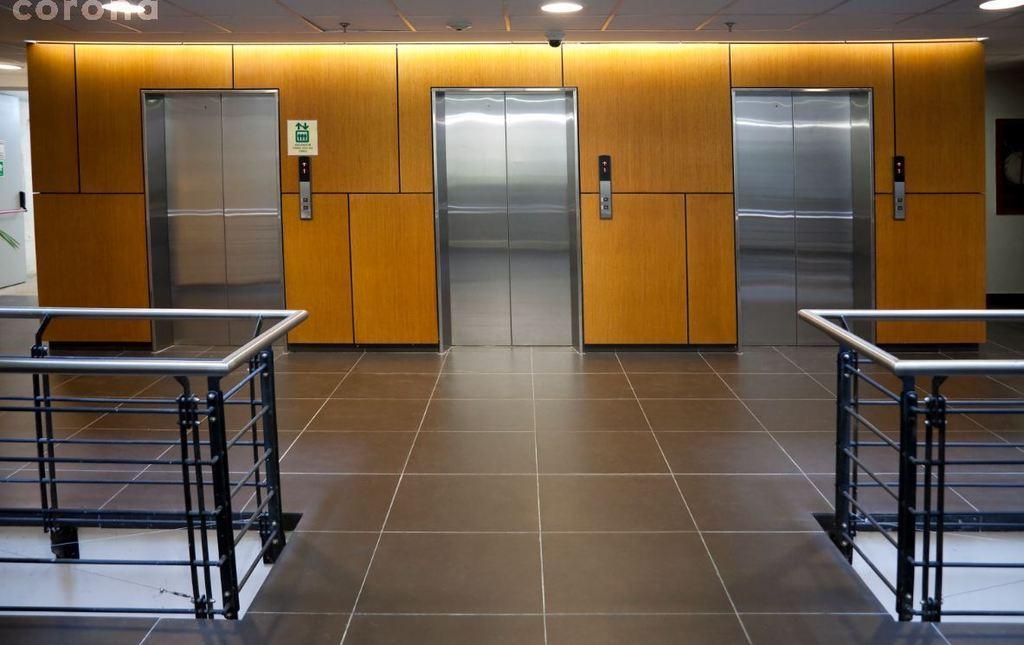Can you describe this image briefly? In this image, we can see the floor and we can see three lifts. 